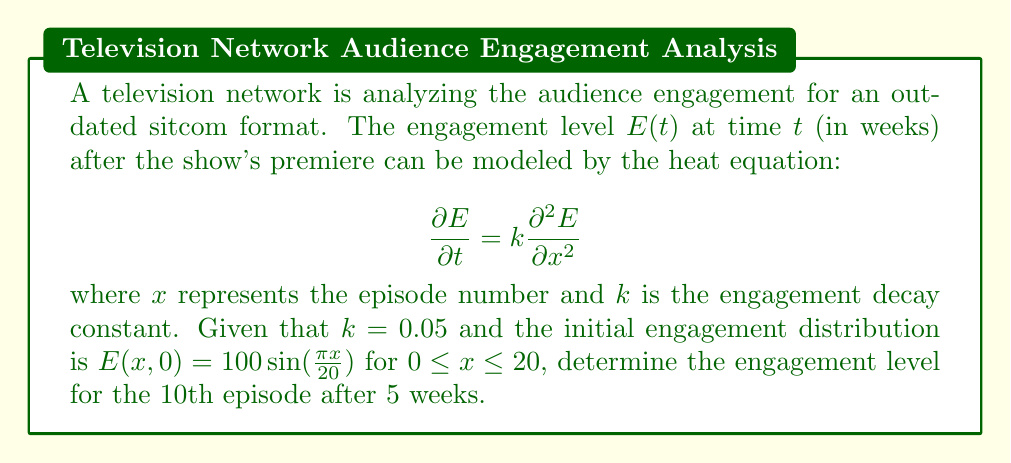Help me with this question. To solve this problem, we'll use the separation of variables method for the heat equation:

1) The general solution for the heat equation is:
   $$E(x,t) = \sum_{n=1}^{\infty} B_n \sin(\frac{n\pi x}{L})e^{-k(\frac{n\pi}{L})^2t}$$

2) In our case, $L = 20$ and the initial condition matches the first term of this series with $n = 1$:
   $$E(x,0) = 100\sin(\frac{\pi x}{20})$$

3) Therefore, $B_1 = 100$ and $B_n = 0$ for $n > 1$. Our solution simplifies to:
   $$E(x,t) = 100\sin(\frac{\pi x}{20})e^{-k(\frac{\pi}{20})^2t}$$

4) Substituting the given values:
   $k = 0.05$, $x = 10$ (10th episode), $t = 5$ (5 weeks)

5) Calculate:
   $$E(10,5) = 100\sin(\frac{\pi \cdot 10}{20})e^{-0.05(\frac{\pi}{20})^2 \cdot 5}$$
   $$= 100\sin(\frac{\pi}{2})e^{-0.05(\frac{\pi}{20})^2 \cdot 5}$$
   $$= 100 \cdot 1 \cdot e^{-0.0061685}$$
   $$\approx 99.3851$$

Thus, the engagement level for the 10th episode after 5 weeks is approximately 99.3851.
Answer: 99.3851 